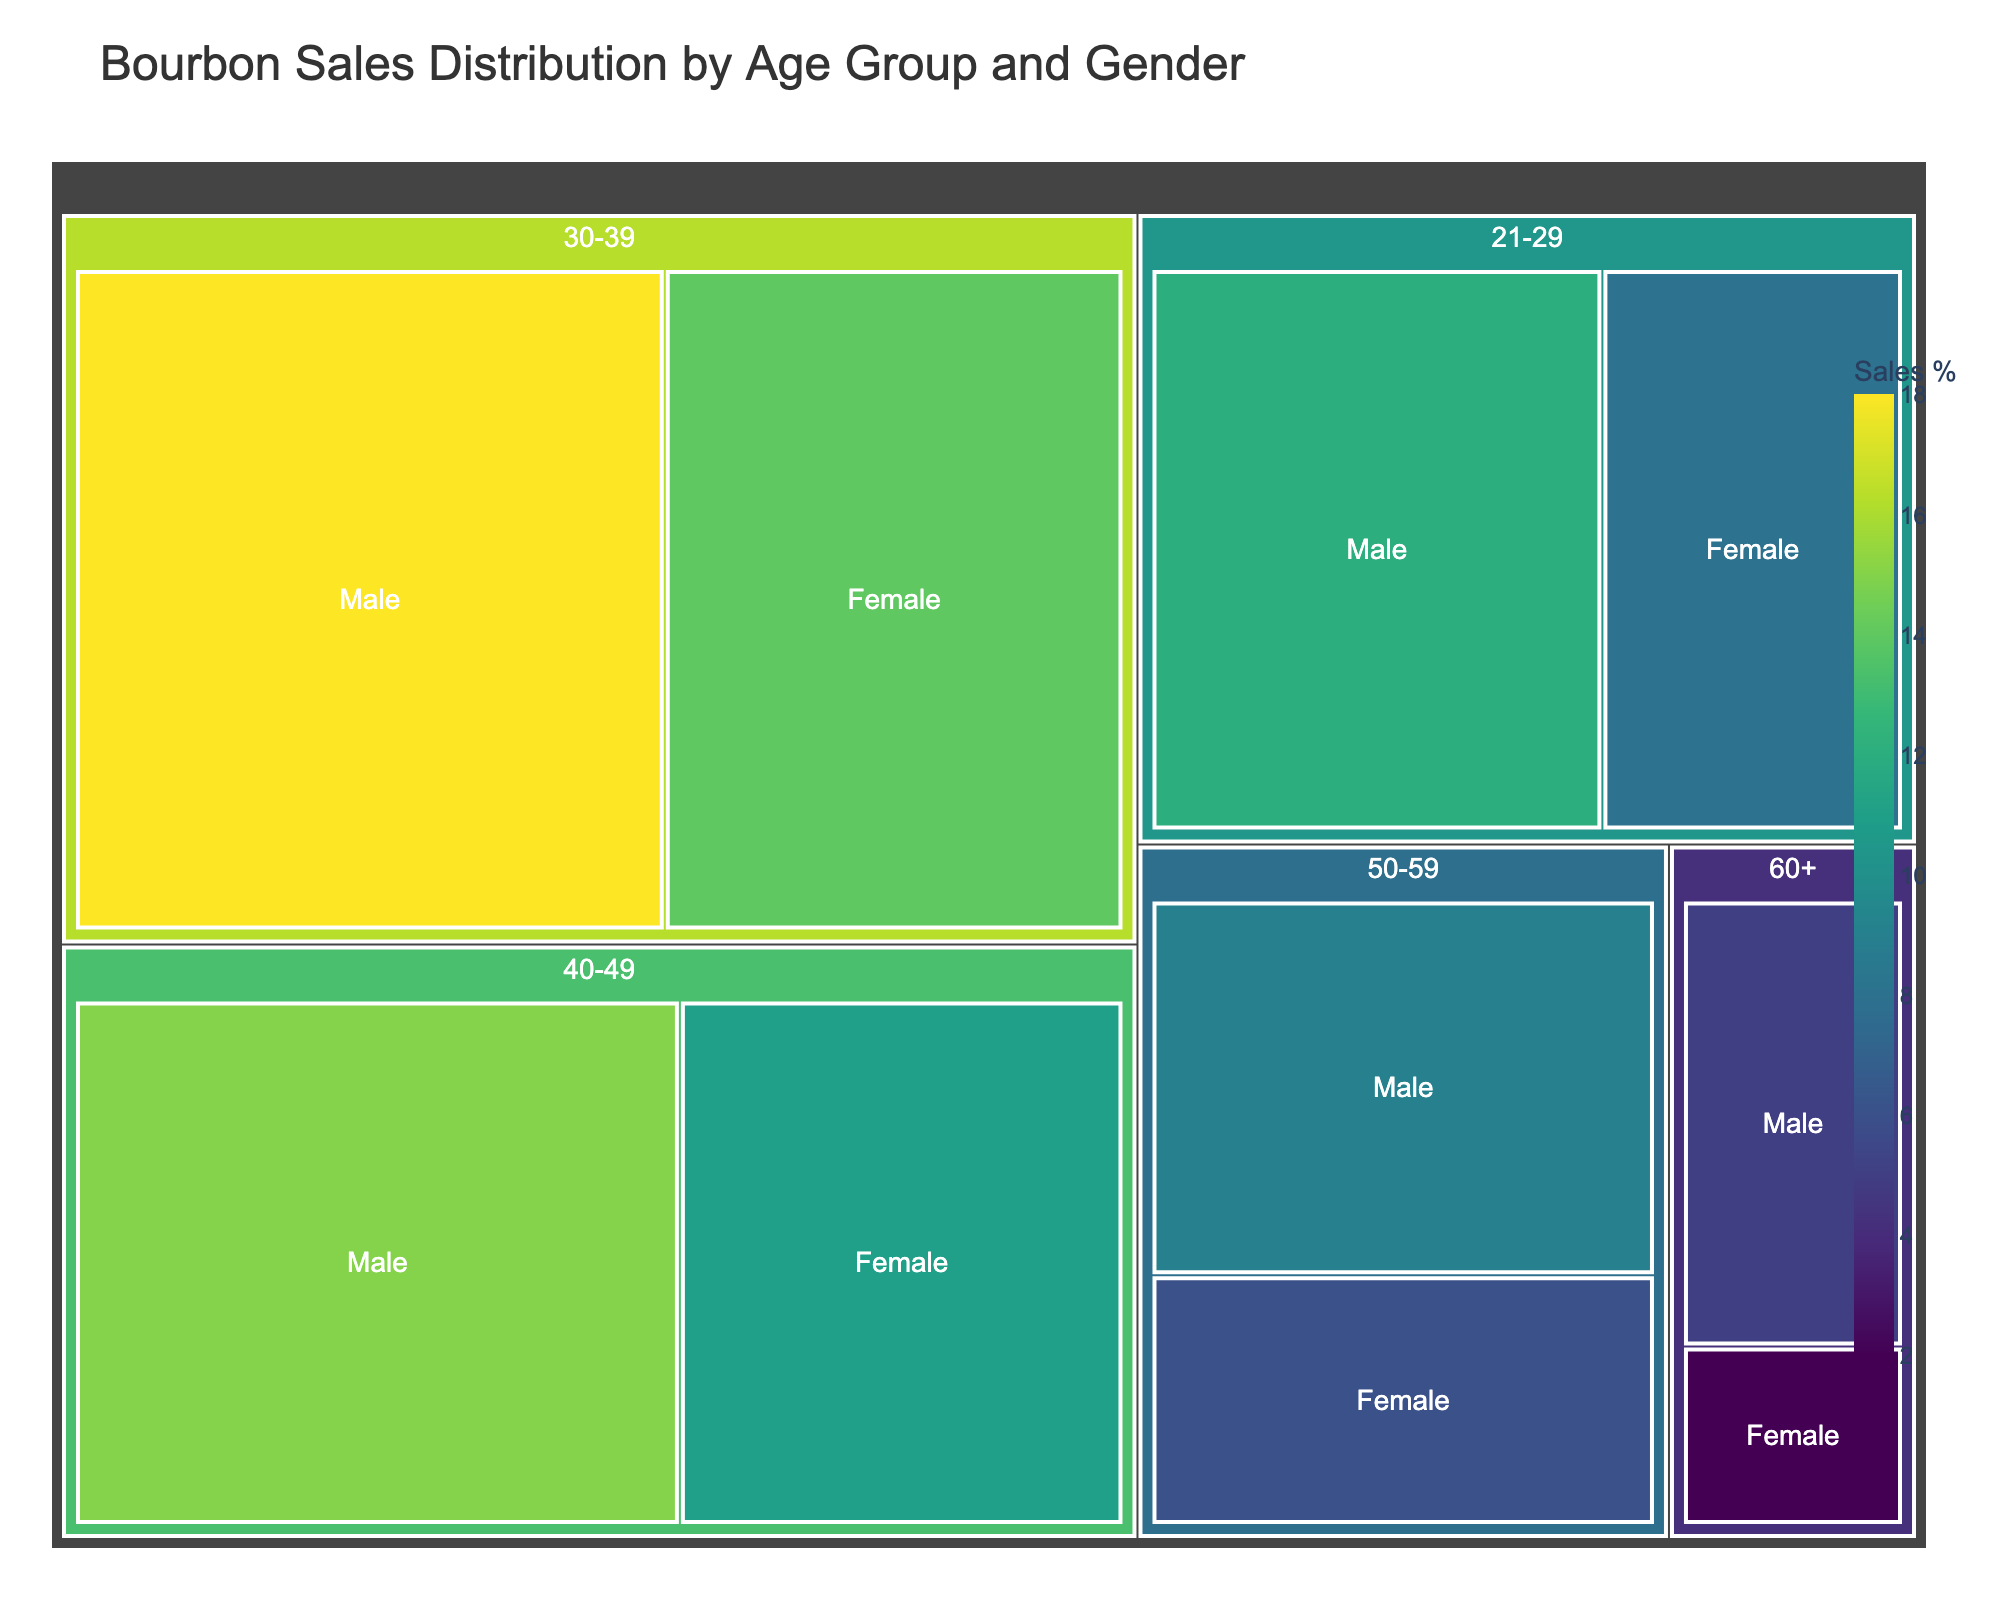What age group has the highest sales percentage? Look for the largest section in the Treemap, which is 30-39 for both males and females. This indicates the highest sales percentage.
Answer: 30-39 What's the total sales percentage for males aged 30-39 and 40-49? Add the percentages for males in these age groups: 18% (30-39) + 15% (40-49) = 33%.
Answer: 33% How does the sales percentage of females aged 30-39 compare to males aged 50-59? Compare the values directly: Females aged 30-39 have 14%, while males aged 50-59 have 9%.
Answer: 14% (females aged 30-39) is greater than 9% (males aged 50-59) What is the difference in total sales percentage between males and females aged 21-29? Males have 12% and females have 8%. Subtract the percentages: 12% - 8% = 4%.
Answer: 4% Which gender has more sales in the 40-49 age group? Compare the figures within the 40-49 age group: Males at 15% and females at 11%.
Answer: Males How much is the combined sales percentage for females aged 40-49 and 21-29? Add the percentages: 11% (40-49) + 8% (21-29) = 19%.
Answer: 19% What's the most notable trend with age groups in terms of sales percentage? As we move to older age groups, the sales percentage tends to decrease.
Answer: Sales percentage decreases with age Which age group has the lowest sales percentage, and what are the values for both genders? Look at the smallest sections; the 60+ age group has males at 5% and females at 2%.
Answer: 60+: 5% (males), 2% (females) What is the average sales percentage for the 50-59 age group? Add the percentages for both genders and divide by 2: (9% + 6%) / 2 = 7.5%.
Answer: 7.5% How does the bourbon sales distribution by gender differ across all age groups? Females consistently have lower sales percentages compared to males in each age group.
Answer: Males higher 